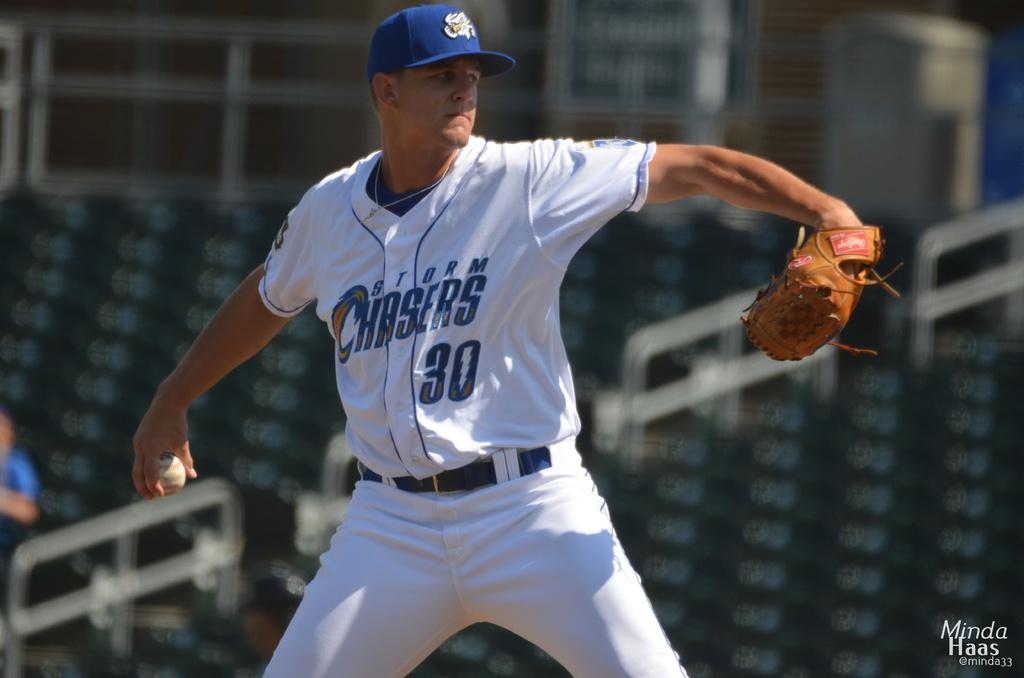<image>
Write a terse but informative summary of the picture. storm chasers baseball pitches getting ready to throw the ball 